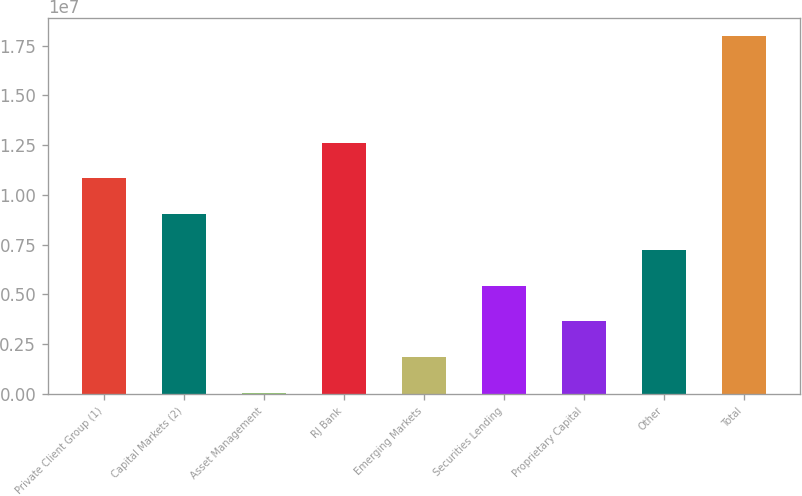Convert chart. <chart><loc_0><loc_0><loc_500><loc_500><bar_chart><fcel>Private Client Group (1)<fcel>Capital Markets (2)<fcel>Asset Management<fcel>RJ Bank<fcel>Emerging Markets<fcel>Securities Lending<fcel>Proprietary Capital<fcel>Other<fcel>Total<nl><fcel>1.08289e+07<fcel>9.03439e+06<fcel>61793<fcel>1.26234e+07<fcel>1.85631e+06<fcel>5.44535e+06<fcel>3.65083e+06<fcel>7.23987e+06<fcel>1.8007e+07<nl></chart> 